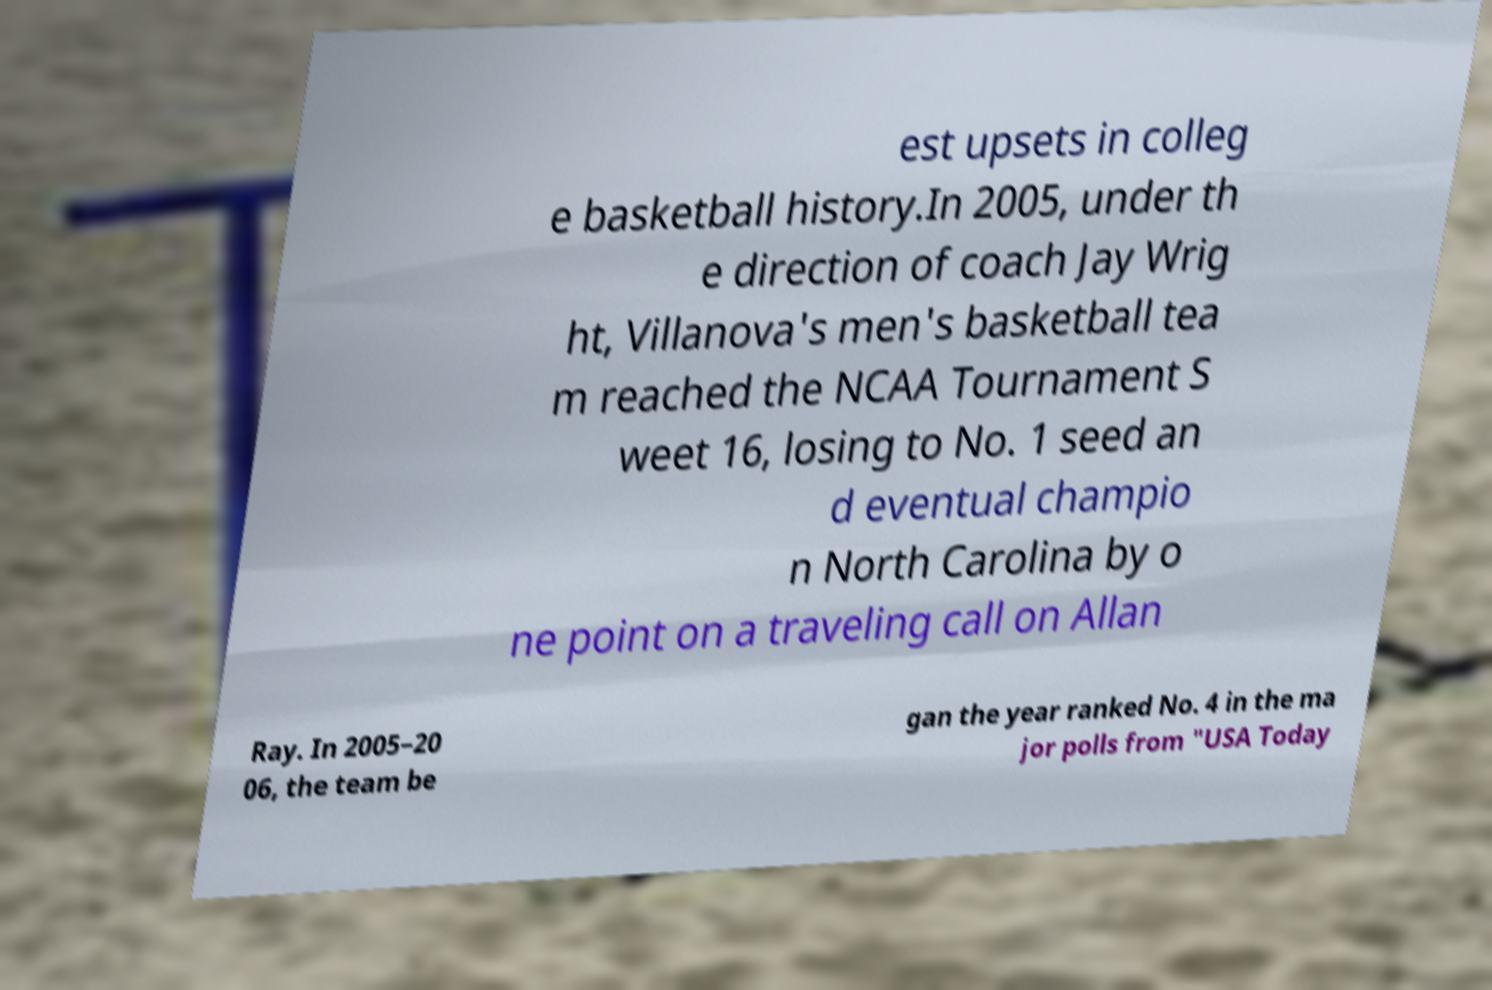Can you accurately transcribe the text from the provided image for me? est upsets in colleg e basketball history.In 2005, under th e direction of coach Jay Wrig ht, Villanova's men's basketball tea m reached the NCAA Tournament S weet 16, losing to No. 1 seed an d eventual champio n North Carolina by o ne point on a traveling call on Allan Ray. In 2005–20 06, the team be gan the year ranked No. 4 in the ma jor polls from "USA Today 